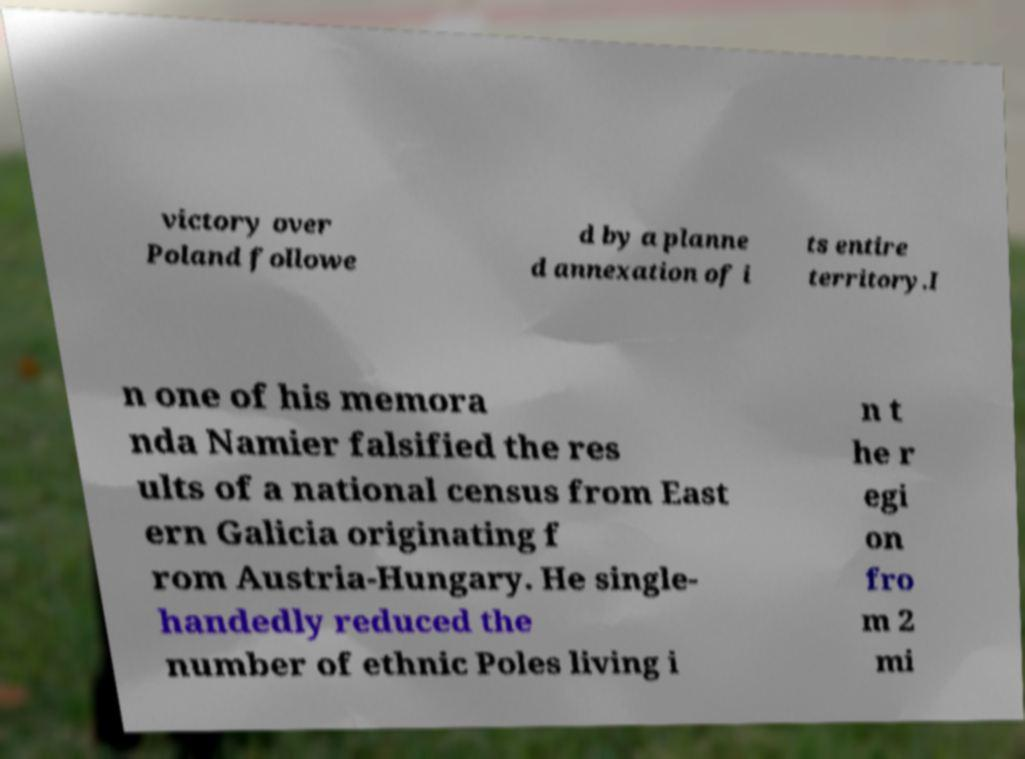Can you accurately transcribe the text from the provided image for me? victory over Poland followe d by a planne d annexation of i ts entire territory.I n one of his memora nda Namier falsified the res ults of a national census from East ern Galicia originating f rom Austria-Hungary. He single- handedly reduced the number of ethnic Poles living i n t he r egi on fro m 2 mi 